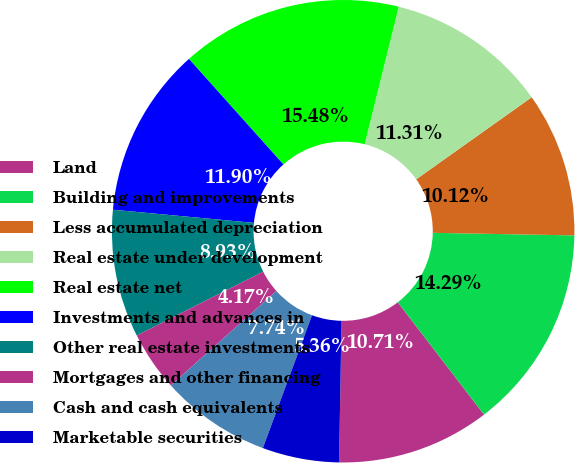Convert chart to OTSL. <chart><loc_0><loc_0><loc_500><loc_500><pie_chart><fcel>Land<fcel>Building and improvements<fcel>Less accumulated depreciation<fcel>Real estate under development<fcel>Real estate net<fcel>Investments and advances in<fcel>Other real estate investments<fcel>Mortgages and other financing<fcel>Cash and cash equivalents<fcel>Marketable securities<nl><fcel>10.71%<fcel>14.29%<fcel>10.12%<fcel>11.31%<fcel>15.48%<fcel>11.9%<fcel>8.93%<fcel>4.17%<fcel>7.74%<fcel>5.36%<nl></chart> 